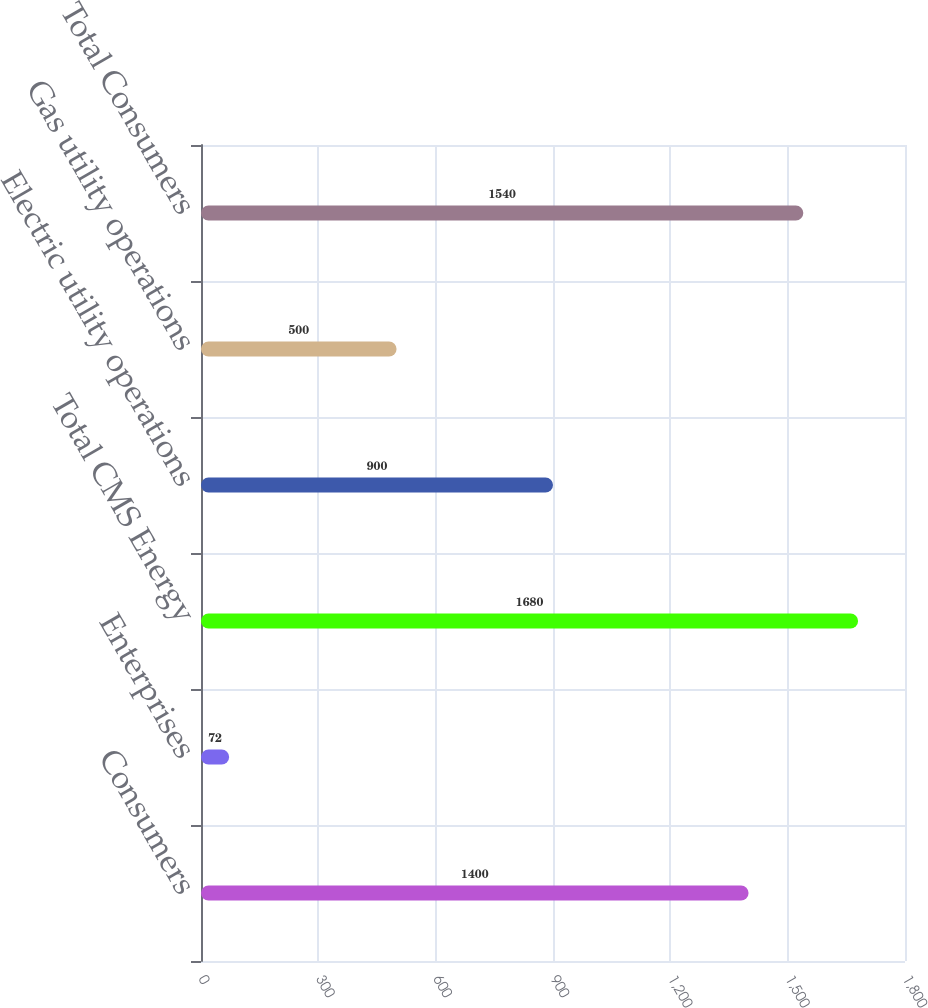Convert chart to OTSL. <chart><loc_0><loc_0><loc_500><loc_500><bar_chart><fcel>Consumers<fcel>Enterprises<fcel>Total CMS Energy<fcel>Electric utility operations<fcel>Gas utility operations<fcel>Total Consumers<nl><fcel>1400<fcel>72<fcel>1680<fcel>900<fcel>500<fcel>1540<nl></chart> 